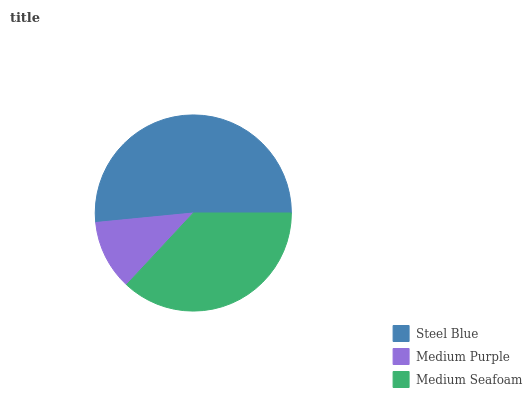Is Medium Purple the minimum?
Answer yes or no. Yes. Is Steel Blue the maximum?
Answer yes or no. Yes. Is Medium Seafoam the minimum?
Answer yes or no. No. Is Medium Seafoam the maximum?
Answer yes or no. No. Is Medium Seafoam greater than Medium Purple?
Answer yes or no. Yes. Is Medium Purple less than Medium Seafoam?
Answer yes or no. Yes. Is Medium Purple greater than Medium Seafoam?
Answer yes or no. No. Is Medium Seafoam less than Medium Purple?
Answer yes or no. No. Is Medium Seafoam the high median?
Answer yes or no. Yes. Is Medium Seafoam the low median?
Answer yes or no. Yes. Is Steel Blue the high median?
Answer yes or no. No. Is Steel Blue the low median?
Answer yes or no. No. 